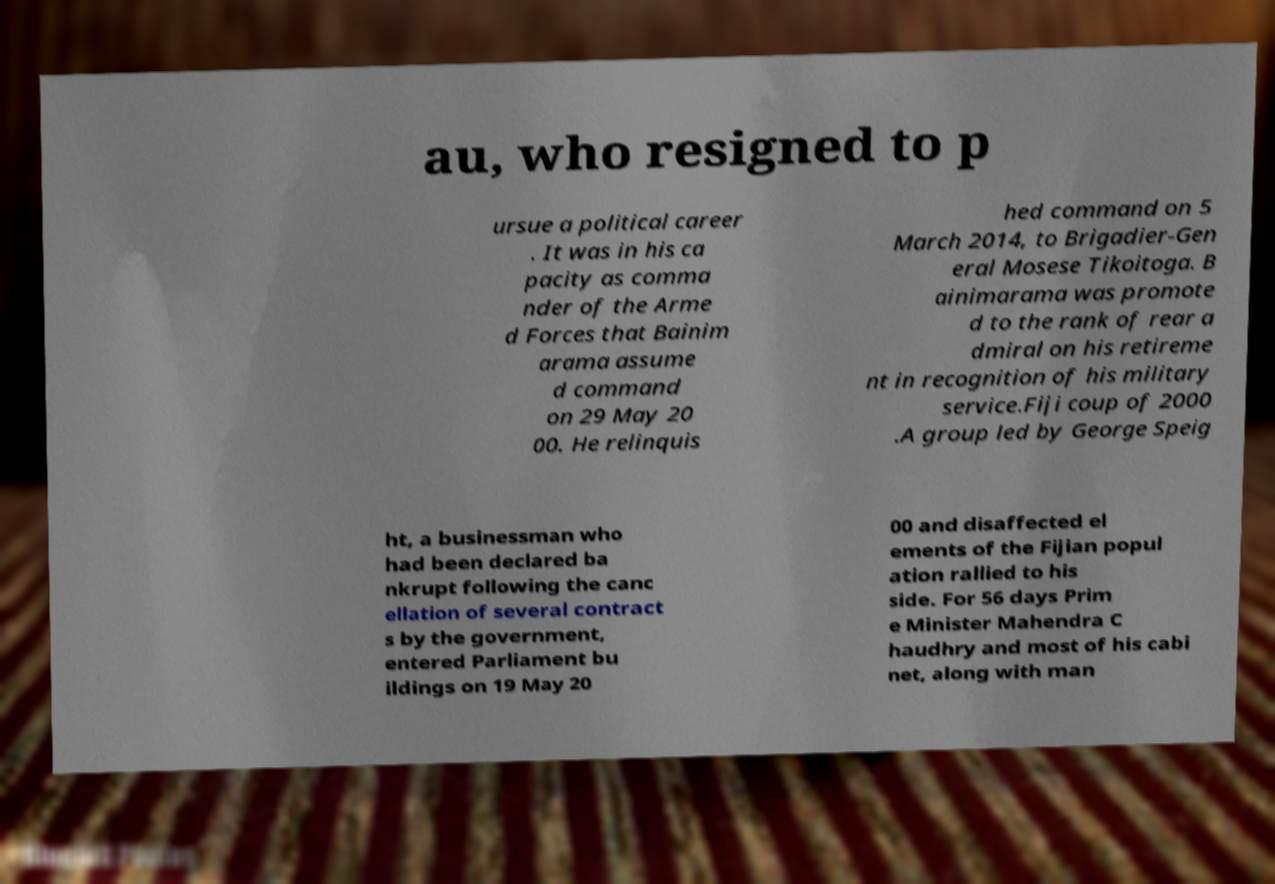Can you read and provide the text displayed in the image?This photo seems to have some interesting text. Can you extract and type it out for me? au, who resigned to p ursue a political career . It was in his ca pacity as comma nder of the Arme d Forces that Bainim arama assume d command on 29 May 20 00. He relinquis hed command on 5 March 2014, to Brigadier-Gen eral Mosese Tikoitoga. B ainimarama was promote d to the rank of rear a dmiral on his retireme nt in recognition of his military service.Fiji coup of 2000 .A group led by George Speig ht, a businessman who had been declared ba nkrupt following the canc ellation of several contract s by the government, entered Parliament bu ildings on 19 May 20 00 and disaffected el ements of the Fijian popul ation rallied to his side. For 56 days Prim e Minister Mahendra C haudhry and most of his cabi net, along with man 